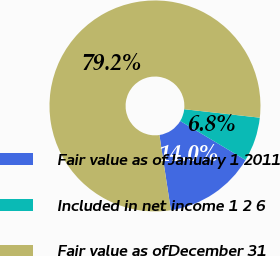<chart> <loc_0><loc_0><loc_500><loc_500><pie_chart><fcel>Fair value as ofJanuary 1 2011<fcel>Included in net income 1 2 6<fcel>Fair value as ofDecember 31<nl><fcel>14.03%<fcel>6.79%<fcel>79.19%<nl></chart> 